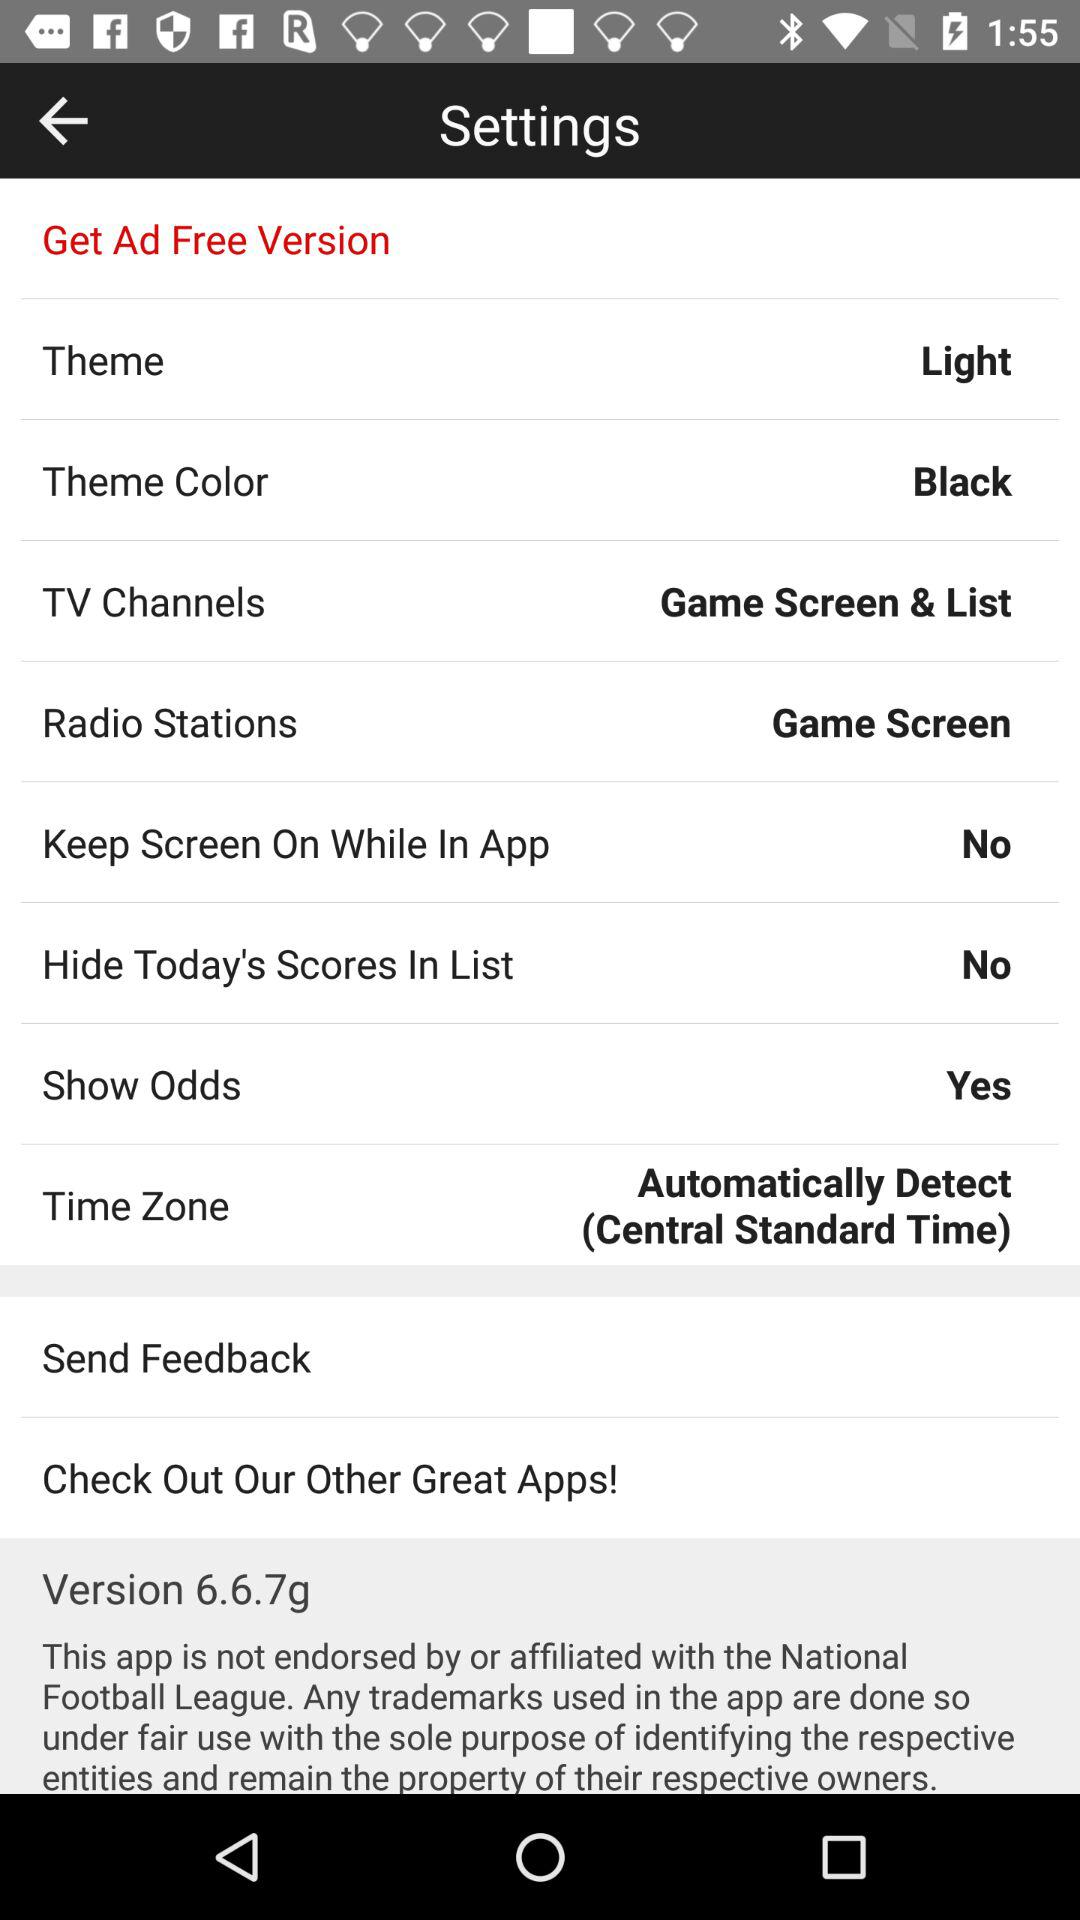What is the status of "Hide Today's Scores In List"? The status is "No". 